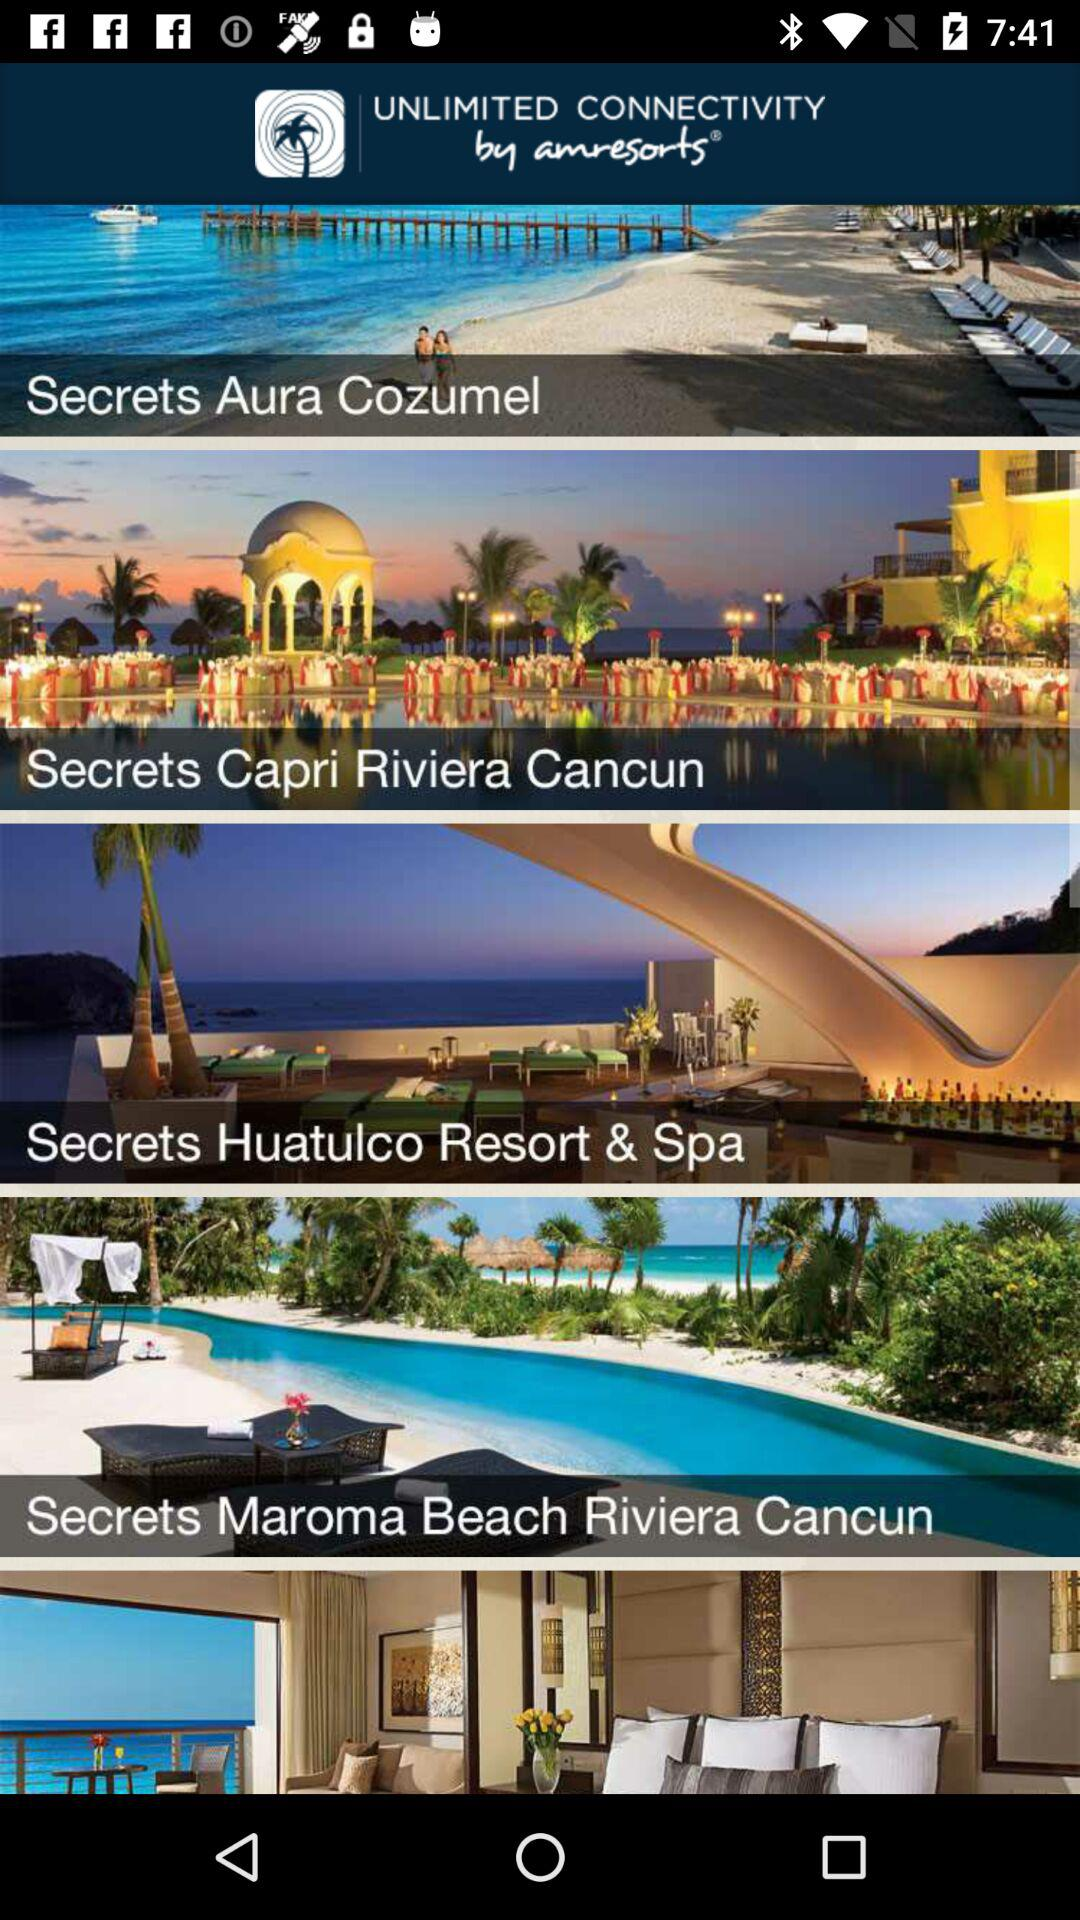What is the app name? The app name is "Unlimited Connectivity". 